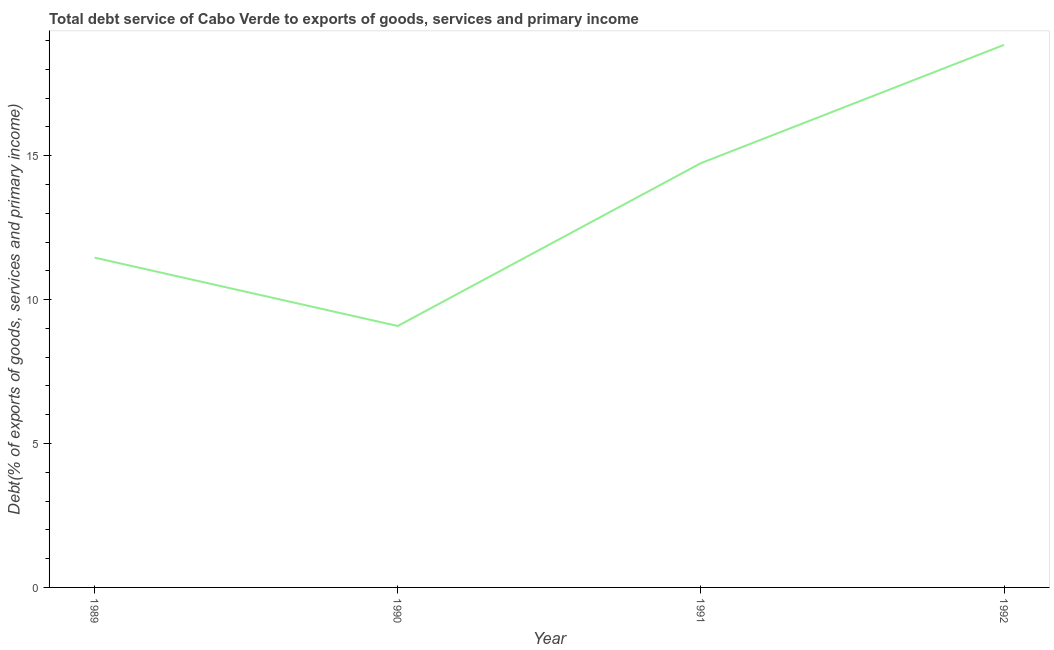What is the total debt service in 1991?
Keep it short and to the point. 14.74. Across all years, what is the maximum total debt service?
Make the answer very short. 18.85. Across all years, what is the minimum total debt service?
Give a very brief answer. 9.08. In which year was the total debt service maximum?
Offer a very short reply. 1992. In which year was the total debt service minimum?
Your answer should be compact. 1990. What is the sum of the total debt service?
Provide a short and direct response. 54.14. What is the difference between the total debt service in 1989 and 1991?
Offer a terse response. -3.28. What is the average total debt service per year?
Give a very brief answer. 13.53. What is the median total debt service?
Ensure brevity in your answer.  13.1. In how many years, is the total debt service greater than 8 %?
Provide a succinct answer. 4. Do a majority of the years between 1991 and 1992 (inclusive) have total debt service greater than 10 %?
Give a very brief answer. Yes. What is the ratio of the total debt service in 1989 to that in 1990?
Your response must be concise. 1.26. Is the total debt service in 1989 less than that in 1992?
Your answer should be compact. Yes. What is the difference between the highest and the second highest total debt service?
Your answer should be very brief. 4.11. What is the difference between the highest and the lowest total debt service?
Keep it short and to the point. 9.77. How many lines are there?
Provide a short and direct response. 1. How many years are there in the graph?
Your response must be concise. 4. Does the graph contain grids?
Provide a succinct answer. No. What is the title of the graph?
Your answer should be compact. Total debt service of Cabo Verde to exports of goods, services and primary income. What is the label or title of the Y-axis?
Provide a succinct answer. Debt(% of exports of goods, services and primary income). What is the Debt(% of exports of goods, services and primary income) in 1989?
Ensure brevity in your answer.  11.46. What is the Debt(% of exports of goods, services and primary income) in 1990?
Ensure brevity in your answer.  9.08. What is the Debt(% of exports of goods, services and primary income) of 1991?
Your response must be concise. 14.74. What is the Debt(% of exports of goods, services and primary income) in 1992?
Your answer should be compact. 18.85. What is the difference between the Debt(% of exports of goods, services and primary income) in 1989 and 1990?
Keep it short and to the point. 2.37. What is the difference between the Debt(% of exports of goods, services and primary income) in 1989 and 1991?
Ensure brevity in your answer.  -3.28. What is the difference between the Debt(% of exports of goods, services and primary income) in 1989 and 1992?
Your answer should be very brief. -7.39. What is the difference between the Debt(% of exports of goods, services and primary income) in 1990 and 1991?
Make the answer very short. -5.66. What is the difference between the Debt(% of exports of goods, services and primary income) in 1990 and 1992?
Provide a short and direct response. -9.77. What is the difference between the Debt(% of exports of goods, services and primary income) in 1991 and 1992?
Provide a short and direct response. -4.11. What is the ratio of the Debt(% of exports of goods, services and primary income) in 1989 to that in 1990?
Provide a succinct answer. 1.26. What is the ratio of the Debt(% of exports of goods, services and primary income) in 1989 to that in 1991?
Provide a succinct answer. 0.78. What is the ratio of the Debt(% of exports of goods, services and primary income) in 1989 to that in 1992?
Provide a succinct answer. 0.61. What is the ratio of the Debt(% of exports of goods, services and primary income) in 1990 to that in 1991?
Your answer should be compact. 0.62. What is the ratio of the Debt(% of exports of goods, services and primary income) in 1990 to that in 1992?
Your answer should be very brief. 0.48. What is the ratio of the Debt(% of exports of goods, services and primary income) in 1991 to that in 1992?
Give a very brief answer. 0.78. 